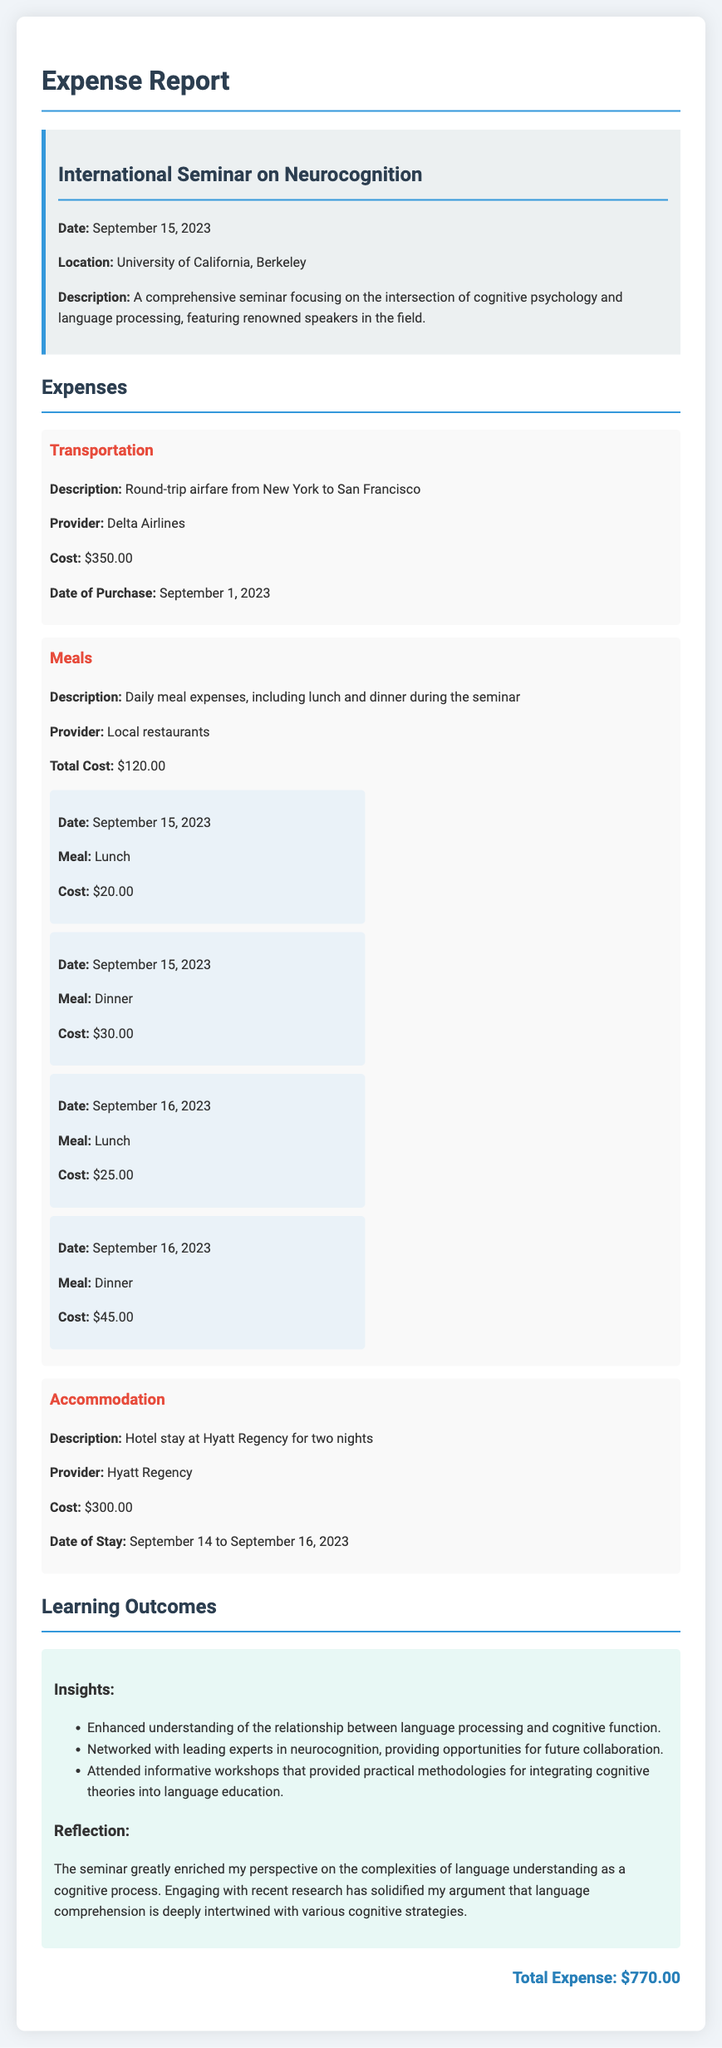What is the total expense? The total expense is summarized at the end of the document, showing the cumulative amount for various categories.
Answer: $770.00 What is the cost of accommodation? The accommodation cost is detailed under the "Accommodation" section, specifying the stay at a hotel.
Answer: $300.00 When did the seminar take place? The seminar date is mentioned in the "event-info" section, indicating when the event occurred.
Answer: September 15, 2023 Who provided the transportation? The transportation provider is listed in the "Transportation" expenses section, detailing the airline service used.
Answer: Delta Airlines What insights were gained from the seminar? Insights are listed under "Learning Outcomes," summarizing the key takeaways from the event.
Answer: Enhanced understanding of the relationship between language processing and cognitive function What was the cost of lunch on September 16, 2023? The meal costs are detailed, including the specific meal costs for each day.
Answer: $25.00 What was the location of the seminar? The seminar location is provided in the "event-info" section, identifying where the event was held.
Answer: University of California, Berkeley What date was the airfare purchased? The date of purchase for the transportation is included in the relevant expense section.
Answer: September 1, 2023 What type of report is this document? The document outlines the nature of the report, indicating its purpose and type in the title.
Answer: Expense Report 